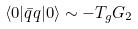Convert formula to latex. <formula><loc_0><loc_0><loc_500><loc_500>\langle 0 | \bar { q } q | 0 \rangle \sim - T _ { g } G _ { 2 }</formula> 